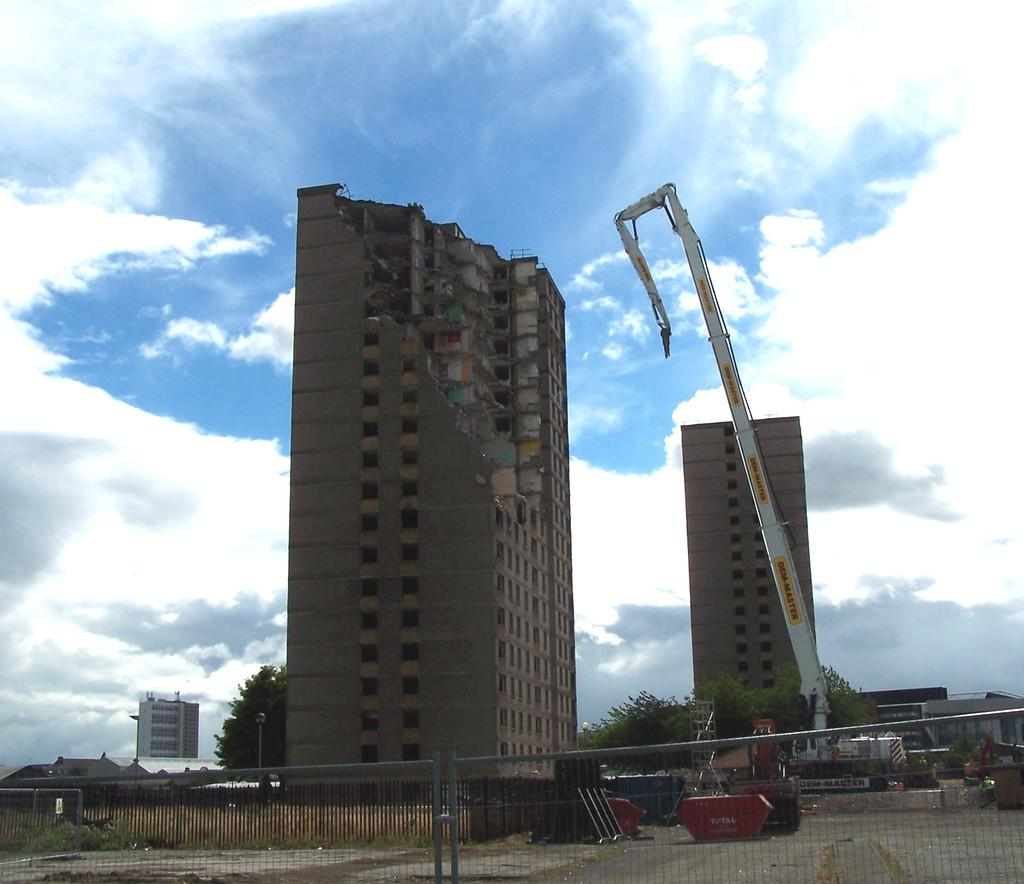What is located in the foreground of the image? There is a gate in the foreground of the image. What structures are visible behind the gate? There are three buildings behind the gate. What type of vegetation can be seen in the image? There are trees visible in the image. What type of machinery is present in the image? There is a crane in the image. What other objects can be seen in the image? There are other objects in the image, but their specific details are not mentioned in the provided facts. What time of day is depicted in the image? The provided facts do not mention the time of day, so it cannot be determined from the image. 